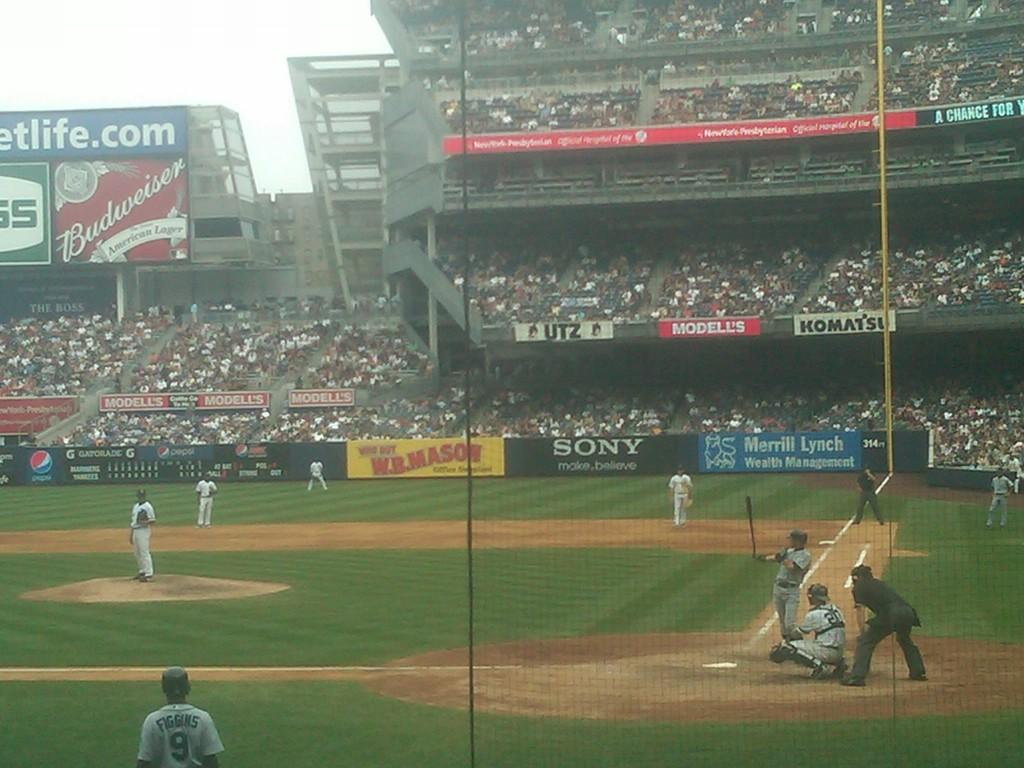<image>
Render a clear and concise summary of the photo. People watch a baseball game in a stadium that has a SONY banner up. 